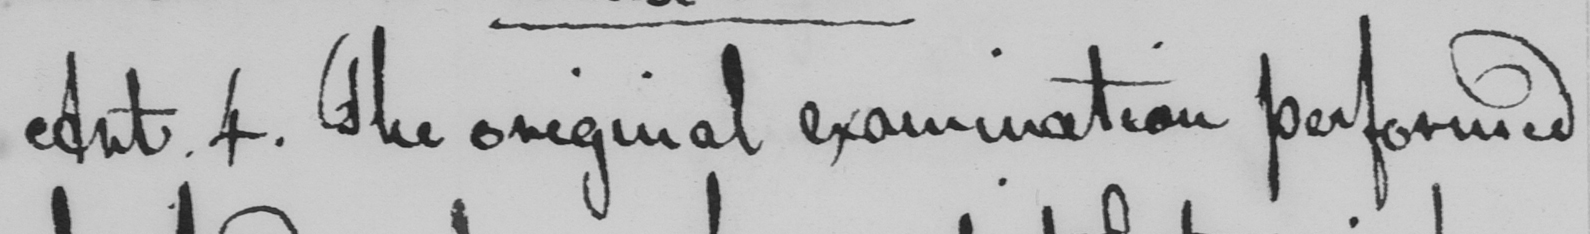Transcribe the text shown in this historical manuscript line. Art . 4 . The original examination performed 